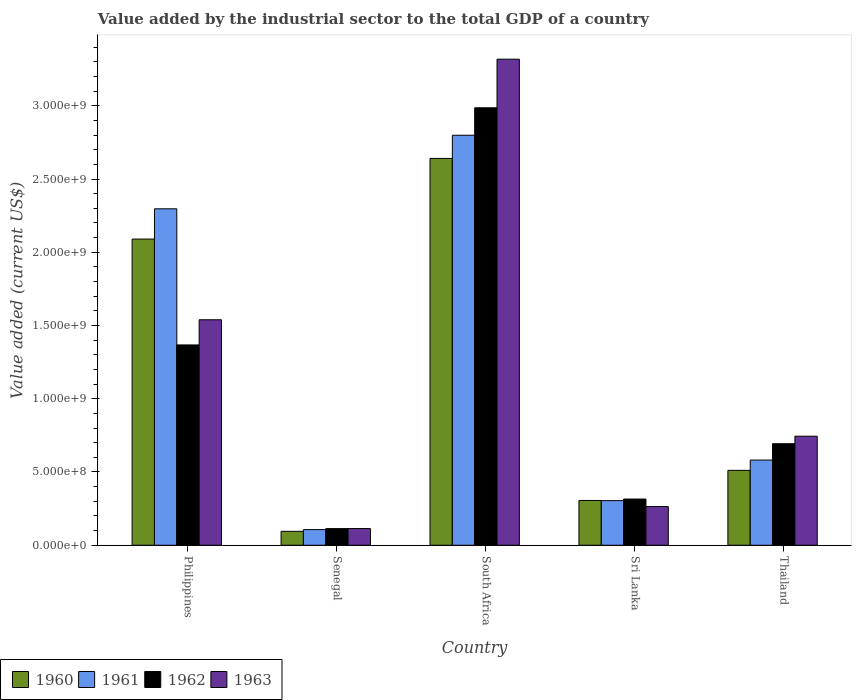How many different coloured bars are there?
Your answer should be compact. 4. How many groups of bars are there?
Offer a very short reply. 5. Are the number of bars per tick equal to the number of legend labels?
Provide a short and direct response. Yes. Are the number of bars on each tick of the X-axis equal?
Provide a succinct answer. Yes. How many bars are there on the 3rd tick from the right?
Provide a succinct answer. 4. What is the label of the 4th group of bars from the left?
Keep it short and to the point. Sri Lanka. In how many cases, is the number of bars for a given country not equal to the number of legend labels?
Offer a very short reply. 0. What is the value added by the industrial sector to the total GDP in 1963 in Sri Lanka?
Offer a very short reply. 2.64e+08. Across all countries, what is the maximum value added by the industrial sector to the total GDP in 1961?
Offer a terse response. 2.80e+09. Across all countries, what is the minimum value added by the industrial sector to the total GDP in 1962?
Provide a succinct answer. 1.13e+08. In which country was the value added by the industrial sector to the total GDP in 1961 maximum?
Your answer should be very brief. South Africa. In which country was the value added by the industrial sector to the total GDP in 1963 minimum?
Keep it short and to the point. Senegal. What is the total value added by the industrial sector to the total GDP in 1962 in the graph?
Provide a short and direct response. 5.48e+09. What is the difference between the value added by the industrial sector to the total GDP in 1962 in South Africa and that in Sri Lanka?
Provide a succinct answer. 2.67e+09. What is the difference between the value added by the industrial sector to the total GDP in 1962 in South Africa and the value added by the industrial sector to the total GDP in 1960 in Thailand?
Your answer should be very brief. 2.48e+09. What is the average value added by the industrial sector to the total GDP in 1962 per country?
Provide a short and direct response. 1.10e+09. What is the difference between the value added by the industrial sector to the total GDP of/in 1962 and value added by the industrial sector to the total GDP of/in 1963 in Senegal?
Give a very brief answer. -4.40e+05. What is the ratio of the value added by the industrial sector to the total GDP in 1963 in Senegal to that in Thailand?
Provide a short and direct response. 0.15. What is the difference between the highest and the second highest value added by the industrial sector to the total GDP in 1962?
Provide a short and direct response. 6.74e+08. What is the difference between the highest and the lowest value added by the industrial sector to the total GDP in 1960?
Keep it short and to the point. 2.55e+09. In how many countries, is the value added by the industrial sector to the total GDP in 1962 greater than the average value added by the industrial sector to the total GDP in 1962 taken over all countries?
Give a very brief answer. 2. Is the sum of the value added by the industrial sector to the total GDP in 1960 in Philippines and South Africa greater than the maximum value added by the industrial sector to the total GDP in 1963 across all countries?
Offer a very short reply. Yes. What does the 1st bar from the left in South Africa represents?
Offer a very short reply. 1960. What does the 4th bar from the right in Sri Lanka represents?
Provide a short and direct response. 1960. Is it the case that in every country, the sum of the value added by the industrial sector to the total GDP in 1961 and value added by the industrial sector to the total GDP in 1963 is greater than the value added by the industrial sector to the total GDP in 1962?
Ensure brevity in your answer.  Yes. How many bars are there?
Offer a very short reply. 20. What is the difference between two consecutive major ticks on the Y-axis?
Offer a terse response. 5.00e+08. Does the graph contain any zero values?
Keep it short and to the point. No. How many legend labels are there?
Your answer should be compact. 4. What is the title of the graph?
Provide a succinct answer. Value added by the industrial sector to the total GDP of a country. Does "2003" appear as one of the legend labels in the graph?
Your response must be concise. No. What is the label or title of the Y-axis?
Your response must be concise. Value added (current US$). What is the Value added (current US$) in 1960 in Philippines?
Your answer should be very brief. 2.09e+09. What is the Value added (current US$) in 1961 in Philippines?
Your answer should be compact. 2.30e+09. What is the Value added (current US$) in 1962 in Philippines?
Provide a succinct answer. 1.37e+09. What is the Value added (current US$) of 1963 in Philippines?
Your response must be concise. 1.54e+09. What is the Value added (current US$) of 1960 in Senegal?
Your answer should be very brief. 9.49e+07. What is the Value added (current US$) of 1961 in Senegal?
Offer a very short reply. 1.07e+08. What is the Value added (current US$) of 1962 in Senegal?
Make the answer very short. 1.13e+08. What is the Value added (current US$) in 1963 in Senegal?
Offer a very short reply. 1.14e+08. What is the Value added (current US$) of 1960 in South Africa?
Give a very brief answer. 2.64e+09. What is the Value added (current US$) in 1961 in South Africa?
Provide a succinct answer. 2.80e+09. What is the Value added (current US$) in 1962 in South Africa?
Your response must be concise. 2.99e+09. What is the Value added (current US$) in 1963 in South Africa?
Offer a terse response. 3.32e+09. What is the Value added (current US$) in 1960 in Sri Lanka?
Give a very brief answer. 3.06e+08. What is the Value added (current US$) of 1961 in Sri Lanka?
Ensure brevity in your answer.  3.04e+08. What is the Value added (current US$) in 1962 in Sri Lanka?
Keep it short and to the point. 3.15e+08. What is the Value added (current US$) of 1963 in Sri Lanka?
Offer a very short reply. 2.64e+08. What is the Value added (current US$) in 1960 in Thailand?
Offer a very short reply. 5.11e+08. What is the Value added (current US$) in 1961 in Thailand?
Give a very brief answer. 5.81e+08. What is the Value added (current US$) in 1962 in Thailand?
Your answer should be compact. 6.93e+08. What is the Value added (current US$) in 1963 in Thailand?
Your response must be concise. 7.44e+08. Across all countries, what is the maximum Value added (current US$) of 1960?
Ensure brevity in your answer.  2.64e+09. Across all countries, what is the maximum Value added (current US$) in 1961?
Keep it short and to the point. 2.80e+09. Across all countries, what is the maximum Value added (current US$) in 1962?
Your response must be concise. 2.99e+09. Across all countries, what is the maximum Value added (current US$) in 1963?
Offer a terse response. 3.32e+09. Across all countries, what is the minimum Value added (current US$) in 1960?
Offer a terse response. 9.49e+07. Across all countries, what is the minimum Value added (current US$) of 1961?
Your response must be concise. 1.07e+08. Across all countries, what is the minimum Value added (current US$) in 1962?
Your response must be concise. 1.13e+08. Across all countries, what is the minimum Value added (current US$) of 1963?
Your response must be concise. 1.14e+08. What is the total Value added (current US$) of 1960 in the graph?
Provide a succinct answer. 5.64e+09. What is the total Value added (current US$) in 1961 in the graph?
Provide a short and direct response. 6.09e+09. What is the total Value added (current US$) in 1962 in the graph?
Your answer should be compact. 5.48e+09. What is the total Value added (current US$) in 1963 in the graph?
Your response must be concise. 5.98e+09. What is the difference between the Value added (current US$) of 1960 in Philippines and that in Senegal?
Your response must be concise. 2.00e+09. What is the difference between the Value added (current US$) of 1961 in Philippines and that in Senegal?
Your response must be concise. 2.19e+09. What is the difference between the Value added (current US$) of 1962 in Philippines and that in Senegal?
Your answer should be very brief. 1.25e+09. What is the difference between the Value added (current US$) of 1963 in Philippines and that in Senegal?
Provide a succinct answer. 1.43e+09. What is the difference between the Value added (current US$) of 1960 in Philippines and that in South Africa?
Provide a succinct answer. -5.50e+08. What is the difference between the Value added (current US$) in 1961 in Philippines and that in South Africa?
Your response must be concise. -5.02e+08. What is the difference between the Value added (current US$) of 1962 in Philippines and that in South Africa?
Make the answer very short. -1.62e+09. What is the difference between the Value added (current US$) of 1963 in Philippines and that in South Africa?
Provide a succinct answer. -1.78e+09. What is the difference between the Value added (current US$) of 1960 in Philippines and that in Sri Lanka?
Ensure brevity in your answer.  1.78e+09. What is the difference between the Value added (current US$) of 1961 in Philippines and that in Sri Lanka?
Offer a very short reply. 1.99e+09. What is the difference between the Value added (current US$) of 1962 in Philippines and that in Sri Lanka?
Make the answer very short. 1.05e+09. What is the difference between the Value added (current US$) in 1963 in Philippines and that in Sri Lanka?
Offer a very short reply. 1.28e+09. What is the difference between the Value added (current US$) in 1960 in Philippines and that in Thailand?
Keep it short and to the point. 1.58e+09. What is the difference between the Value added (current US$) of 1961 in Philippines and that in Thailand?
Your answer should be compact. 1.72e+09. What is the difference between the Value added (current US$) in 1962 in Philippines and that in Thailand?
Keep it short and to the point. 6.74e+08. What is the difference between the Value added (current US$) in 1963 in Philippines and that in Thailand?
Make the answer very short. 7.95e+08. What is the difference between the Value added (current US$) in 1960 in Senegal and that in South Africa?
Your answer should be very brief. -2.55e+09. What is the difference between the Value added (current US$) in 1961 in Senegal and that in South Africa?
Provide a succinct answer. -2.69e+09. What is the difference between the Value added (current US$) of 1962 in Senegal and that in South Africa?
Make the answer very short. -2.87e+09. What is the difference between the Value added (current US$) in 1963 in Senegal and that in South Africa?
Give a very brief answer. -3.20e+09. What is the difference between the Value added (current US$) of 1960 in Senegal and that in Sri Lanka?
Your answer should be very brief. -2.11e+08. What is the difference between the Value added (current US$) of 1961 in Senegal and that in Sri Lanka?
Your response must be concise. -1.98e+08. What is the difference between the Value added (current US$) of 1962 in Senegal and that in Sri Lanka?
Your answer should be very brief. -2.02e+08. What is the difference between the Value added (current US$) in 1963 in Senegal and that in Sri Lanka?
Your answer should be compact. -1.50e+08. What is the difference between the Value added (current US$) of 1960 in Senegal and that in Thailand?
Make the answer very short. -4.16e+08. What is the difference between the Value added (current US$) in 1961 in Senegal and that in Thailand?
Provide a succinct answer. -4.75e+08. What is the difference between the Value added (current US$) in 1962 in Senegal and that in Thailand?
Your answer should be compact. -5.79e+08. What is the difference between the Value added (current US$) of 1963 in Senegal and that in Thailand?
Offer a very short reply. -6.31e+08. What is the difference between the Value added (current US$) of 1960 in South Africa and that in Sri Lanka?
Ensure brevity in your answer.  2.33e+09. What is the difference between the Value added (current US$) in 1961 in South Africa and that in Sri Lanka?
Your answer should be very brief. 2.49e+09. What is the difference between the Value added (current US$) of 1962 in South Africa and that in Sri Lanka?
Provide a short and direct response. 2.67e+09. What is the difference between the Value added (current US$) in 1963 in South Africa and that in Sri Lanka?
Your response must be concise. 3.05e+09. What is the difference between the Value added (current US$) in 1960 in South Africa and that in Thailand?
Keep it short and to the point. 2.13e+09. What is the difference between the Value added (current US$) in 1961 in South Africa and that in Thailand?
Keep it short and to the point. 2.22e+09. What is the difference between the Value added (current US$) in 1962 in South Africa and that in Thailand?
Make the answer very short. 2.29e+09. What is the difference between the Value added (current US$) in 1963 in South Africa and that in Thailand?
Keep it short and to the point. 2.57e+09. What is the difference between the Value added (current US$) of 1960 in Sri Lanka and that in Thailand?
Your response must be concise. -2.06e+08. What is the difference between the Value added (current US$) in 1961 in Sri Lanka and that in Thailand?
Give a very brief answer. -2.77e+08. What is the difference between the Value added (current US$) in 1962 in Sri Lanka and that in Thailand?
Give a very brief answer. -3.78e+08. What is the difference between the Value added (current US$) in 1963 in Sri Lanka and that in Thailand?
Your answer should be very brief. -4.80e+08. What is the difference between the Value added (current US$) of 1960 in Philippines and the Value added (current US$) of 1961 in Senegal?
Offer a terse response. 1.98e+09. What is the difference between the Value added (current US$) in 1960 in Philippines and the Value added (current US$) in 1962 in Senegal?
Give a very brief answer. 1.98e+09. What is the difference between the Value added (current US$) in 1960 in Philippines and the Value added (current US$) in 1963 in Senegal?
Keep it short and to the point. 1.98e+09. What is the difference between the Value added (current US$) of 1961 in Philippines and the Value added (current US$) of 1962 in Senegal?
Give a very brief answer. 2.18e+09. What is the difference between the Value added (current US$) of 1961 in Philippines and the Value added (current US$) of 1963 in Senegal?
Give a very brief answer. 2.18e+09. What is the difference between the Value added (current US$) in 1962 in Philippines and the Value added (current US$) in 1963 in Senegal?
Offer a terse response. 1.25e+09. What is the difference between the Value added (current US$) of 1960 in Philippines and the Value added (current US$) of 1961 in South Africa?
Your answer should be compact. -7.09e+08. What is the difference between the Value added (current US$) of 1960 in Philippines and the Value added (current US$) of 1962 in South Africa?
Provide a short and direct response. -8.96e+08. What is the difference between the Value added (current US$) in 1960 in Philippines and the Value added (current US$) in 1963 in South Africa?
Provide a short and direct response. -1.23e+09. What is the difference between the Value added (current US$) of 1961 in Philippines and the Value added (current US$) of 1962 in South Africa?
Your answer should be compact. -6.90e+08. What is the difference between the Value added (current US$) of 1961 in Philippines and the Value added (current US$) of 1963 in South Africa?
Offer a very short reply. -1.02e+09. What is the difference between the Value added (current US$) in 1962 in Philippines and the Value added (current US$) in 1963 in South Africa?
Ensure brevity in your answer.  -1.95e+09. What is the difference between the Value added (current US$) in 1960 in Philippines and the Value added (current US$) in 1961 in Sri Lanka?
Ensure brevity in your answer.  1.79e+09. What is the difference between the Value added (current US$) in 1960 in Philippines and the Value added (current US$) in 1962 in Sri Lanka?
Provide a short and direct response. 1.77e+09. What is the difference between the Value added (current US$) in 1960 in Philippines and the Value added (current US$) in 1963 in Sri Lanka?
Ensure brevity in your answer.  1.83e+09. What is the difference between the Value added (current US$) of 1961 in Philippines and the Value added (current US$) of 1962 in Sri Lanka?
Your answer should be compact. 1.98e+09. What is the difference between the Value added (current US$) in 1961 in Philippines and the Value added (current US$) in 1963 in Sri Lanka?
Make the answer very short. 2.03e+09. What is the difference between the Value added (current US$) in 1962 in Philippines and the Value added (current US$) in 1963 in Sri Lanka?
Ensure brevity in your answer.  1.10e+09. What is the difference between the Value added (current US$) in 1960 in Philippines and the Value added (current US$) in 1961 in Thailand?
Provide a short and direct response. 1.51e+09. What is the difference between the Value added (current US$) in 1960 in Philippines and the Value added (current US$) in 1962 in Thailand?
Offer a terse response. 1.40e+09. What is the difference between the Value added (current US$) of 1960 in Philippines and the Value added (current US$) of 1963 in Thailand?
Your response must be concise. 1.35e+09. What is the difference between the Value added (current US$) in 1961 in Philippines and the Value added (current US$) in 1962 in Thailand?
Your response must be concise. 1.60e+09. What is the difference between the Value added (current US$) of 1961 in Philippines and the Value added (current US$) of 1963 in Thailand?
Make the answer very short. 1.55e+09. What is the difference between the Value added (current US$) of 1962 in Philippines and the Value added (current US$) of 1963 in Thailand?
Keep it short and to the point. 6.23e+08. What is the difference between the Value added (current US$) in 1960 in Senegal and the Value added (current US$) in 1961 in South Africa?
Provide a succinct answer. -2.70e+09. What is the difference between the Value added (current US$) of 1960 in Senegal and the Value added (current US$) of 1962 in South Africa?
Make the answer very short. -2.89e+09. What is the difference between the Value added (current US$) in 1960 in Senegal and the Value added (current US$) in 1963 in South Africa?
Provide a succinct answer. -3.22e+09. What is the difference between the Value added (current US$) of 1961 in Senegal and the Value added (current US$) of 1962 in South Africa?
Make the answer very short. -2.88e+09. What is the difference between the Value added (current US$) in 1961 in Senegal and the Value added (current US$) in 1963 in South Africa?
Your response must be concise. -3.21e+09. What is the difference between the Value added (current US$) in 1962 in Senegal and the Value added (current US$) in 1963 in South Africa?
Make the answer very short. -3.20e+09. What is the difference between the Value added (current US$) in 1960 in Senegal and the Value added (current US$) in 1961 in Sri Lanka?
Your response must be concise. -2.10e+08. What is the difference between the Value added (current US$) in 1960 in Senegal and the Value added (current US$) in 1962 in Sri Lanka?
Your answer should be compact. -2.20e+08. What is the difference between the Value added (current US$) of 1960 in Senegal and the Value added (current US$) of 1963 in Sri Lanka?
Your answer should be compact. -1.69e+08. What is the difference between the Value added (current US$) of 1961 in Senegal and the Value added (current US$) of 1962 in Sri Lanka?
Provide a short and direct response. -2.08e+08. What is the difference between the Value added (current US$) of 1961 in Senegal and the Value added (current US$) of 1963 in Sri Lanka?
Your answer should be very brief. -1.57e+08. What is the difference between the Value added (current US$) in 1962 in Senegal and the Value added (current US$) in 1963 in Sri Lanka?
Keep it short and to the point. -1.51e+08. What is the difference between the Value added (current US$) of 1960 in Senegal and the Value added (current US$) of 1961 in Thailand?
Offer a very short reply. -4.87e+08. What is the difference between the Value added (current US$) of 1960 in Senegal and the Value added (current US$) of 1962 in Thailand?
Your answer should be very brief. -5.98e+08. What is the difference between the Value added (current US$) in 1960 in Senegal and the Value added (current US$) in 1963 in Thailand?
Keep it short and to the point. -6.50e+08. What is the difference between the Value added (current US$) in 1961 in Senegal and the Value added (current US$) in 1962 in Thailand?
Make the answer very short. -5.86e+08. What is the difference between the Value added (current US$) in 1961 in Senegal and the Value added (current US$) in 1963 in Thailand?
Provide a succinct answer. -6.38e+08. What is the difference between the Value added (current US$) in 1962 in Senegal and the Value added (current US$) in 1963 in Thailand?
Keep it short and to the point. -6.31e+08. What is the difference between the Value added (current US$) in 1960 in South Africa and the Value added (current US$) in 1961 in Sri Lanka?
Make the answer very short. 2.34e+09. What is the difference between the Value added (current US$) of 1960 in South Africa and the Value added (current US$) of 1962 in Sri Lanka?
Your answer should be compact. 2.33e+09. What is the difference between the Value added (current US$) of 1960 in South Africa and the Value added (current US$) of 1963 in Sri Lanka?
Provide a succinct answer. 2.38e+09. What is the difference between the Value added (current US$) in 1961 in South Africa and the Value added (current US$) in 1962 in Sri Lanka?
Make the answer very short. 2.48e+09. What is the difference between the Value added (current US$) in 1961 in South Africa and the Value added (current US$) in 1963 in Sri Lanka?
Keep it short and to the point. 2.53e+09. What is the difference between the Value added (current US$) of 1962 in South Africa and the Value added (current US$) of 1963 in Sri Lanka?
Provide a short and direct response. 2.72e+09. What is the difference between the Value added (current US$) in 1960 in South Africa and the Value added (current US$) in 1961 in Thailand?
Ensure brevity in your answer.  2.06e+09. What is the difference between the Value added (current US$) in 1960 in South Africa and the Value added (current US$) in 1962 in Thailand?
Provide a succinct answer. 1.95e+09. What is the difference between the Value added (current US$) in 1960 in South Africa and the Value added (current US$) in 1963 in Thailand?
Your answer should be compact. 1.90e+09. What is the difference between the Value added (current US$) of 1961 in South Africa and the Value added (current US$) of 1962 in Thailand?
Your answer should be compact. 2.11e+09. What is the difference between the Value added (current US$) of 1961 in South Africa and the Value added (current US$) of 1963 in Thailand?
Offer a very short reply. 2.05e+09. What is the difference between the Value added (current US$) in 1962 in South Africa and the Value added (current US$) in 1963 in Thailand?
Make the answer very short. 2.24e+09. What is the difference between the Value added (current US$) of 1960 in Sri Lanka and the Value added (current US$) of 1961 in Thailand?
Offer a terse response. -2.76e+08. What is the difference between the Value added (current US$) of 1960 in Sri Lanka and the Value added (current US$) of 1962 in Thailand?
Your answer should be compact. -3.87e+08. What is the difference between the Value added (current US$) of 1960 in Sri Lanka and the Value added (current US$) of 1963 in Thailand?
Keep it short and to the point. -4.39e+08. What is the difference between the Value added (current US$) in 1961 in Sri Lanka and the Value added (current US$) in 1962 in Thailand?
Offer a very short reply. -3.89e+08. What is the difference between the Value added (current US$) in 1961 in Sri Lanka and the Value added (current US$) in 1963 in Thailand?
Your answer should be compact. -4.40e+08. What is the difference between the Value added (current US$) of 1962 in Sri Lanka and the Value added (current US$) of 1963 in Thailand?
Ensure brevity in your answer.  -4.29e+08. What is the average Value added (current US$) in 1960 per country?
Keep it short and to the point. 1.13e+09. What is the average Value added (current US$) in 1961 per country?
Offer a terse response. 1.22e+09. What is the average Value added (current US$) of 1962 per country?
Keep it short and to the point. 1.10e+09. What is the average Value added (current US$) of 1963 per country?
Provide a short and direct response. 1.20e+09. What is the difference between the Value added (current US$) in 1960 and Value added (current US$) in 1961 in Philippines?
Offer a very short reply. -2.07e+08. What is the difference between the Value added (current US$) in 1960 and Value added (current US$) in 1962 in Philippines?
Your answer should be very brief. 7.23e+08. What is the difference between the Value added (current US$) in 1960 and Value added (current US$) in 1963 in Philippines?
Your answer should be very brief. 5.51e+08. What is the difference between the Value added (current US$) of 1961 and Value added (current US$) of 1962 in Philippines?
Offer a very short reply. 9.29e+08. What is the difference between the Value added (current US$) of 1961 and Value added (current US$) of 1963 in Philippines?
Make the answer very short. 7.57e+08. What is the difference between the Value added (current US$) of 1962 and Value added (current US$) of 1963 in Philippines?
Your answer should be very brief. -1.72e+08. What is the difference between the Value added (current US$) in 1960 and Value added (current US$) in 1961 in Senegal?
Provide a short and direct response. -1.19e+07. What is the difference between the Value added (current US$) of 1960 and Value added (current US$) of 1962 in Senegal?
Your answer should be compact. -1.86e+07. What is the difference between the Value added (current US$) of 1960 and Value added (current US$) of 1963 in Senegal?
Your answer should be compact. -1.91e+07. What is the difference between the Value added (current US$) of 1961 and Value added (current US$) of 1962 in Senegal?
Provide a succinct answer. -6.73e+06. What is the difference between the Value added (current US$) of 1961 and Value added (current US$) of 1963 in Senegal?
Make the answer very short. -7.17e+06. What is the difference between the Value added (current US$) of 1962 and Value added (current US$) of 1963 in Senegal?
Provide a short and direct response. -4.40e+05. What is the difference between the Value added (current US$) of 1960 and Value added (current US$) of 1961 in South Africa?
Give a very brief answer. -1.58e+08. What is the difference between the Value added (current US$) of 1960 and Value added (current US$) of 1962 in South Africa?
Give a very brief answer. -3.46e+08. What is the difference between the Value added (current US$) in 1960 and Value added (current US$) in 1963 in South Africa?
Your answer should be compact. -6.78e+08. What is the difference between the Value added (current US$) in 1961 and Value added (current US$) in 1962 in South Africa?
Provide a short and direct response. -1.87e+08. What is the difference between the Value added (current US$) of 1961 and Value added (current US$) of 1963 in South Africa?
Offer a terse response. -5.19e+08. What is the difference between the Value added (current US$) in 1962 and Value added (current US$) in 1963 in South Africa?
Offer a terse response. -3.32e+08. What is the difference between the Value added (current US$) of 1960 and Value added (current US$) of 1961 in Sri Lanka?
Your response must be concise. 1.26e+06. What is the difference between the Value added (current US$) of 1960 and Value added (current US$) of 1962 in Sri Lanka?
Offer a very short reply. -9.55e+06. What is the difference between the Value added (current US$) of 1960 and Value added (current US$) of 1963 in Sri Lanka?
Make the answer very short. 4.16e+07. What is the difference between the Value added (current US$) in 1961 and Value added (current US$) in 1962 in Sri Lanka?
Your answer should be compact. -1.08e+07. What is the difference between the Value added (current US$) in 1961 and Value added (current US$) in 1963 in Sri Lanka?
Your response must be concise. 4.04e+07. What is the difference between the Value added (current US$) in 1962 and Value added (current US$) in 1963 in Sri Lanka?
Ensure brevity in your answer.  5.12e+07. What is the difference between the Value added (current US$) in 1960 and Value added (current US$) in 1961 in Thailand?
Provide a short and direct response. -7.03e+07. What is the difference between the Value added (current US$) in 1960 and Value added (current US$) in 1962 in Thailand?
Offer a terse response. -1.82e+08. What is the difference between the Value added (current US$) in 1960 and Value added (current US$) in 1963 in Thailand?
Offer a very short reply. -2.33e+08. What is the difference between the Value added (current US$) in 1961 and Value added (current US$) in 1962 in Thailand?
Give a very brief answer. -1.12e+08. What is the difference between the Value added (current US$) in 1961 and Value added (current US$) in 1963 in Thailand?
Keep it short and to the point. -1.63e+08. What is the difference between the Value added (current US$) in 1962 and Value added (current US$) in 1963 in Thailand?
Offer a very short reply. -5.15e+07. What is the ratio of the Value added (current US$) of 1960 in Philippines to that in Senegal?
Your answer should be compact. 22.03. What is the ratio of the Value added (current US$) in 1961 in Philippines to that in Senegal?
Provide a succinct answer. 21.51. What is the ratio of the Value added (current US$) of 1962 in Philippines to that in Senegal?
Give a very brief answer. 12.05. What is the ratio of the Value added (current US$) in 1963 in Philippines to that in Senegal?
Offer a terse response. 13.51. What is the ratio of the Value added (current US$) of 1960 in Philippines to that in South Africa?
Your response must be concise. 0.79. What is the ratio of the Value added (current US$) of 1961 in Philippines to that in South Africa?
Your answer should be very brief. 0.82. What is the ratio of the Value added (current US$) of 1962 in Philippines to that in South Africa?
Make the answer very short. 0.46. What is the ratio of the Value added (current US$) of 1963 in Philippines to that in South Africa?
Your answer should be compact. 0.46. What is the ratio of the Value added (current US$) of 1960 in Philippines to that in Sri Lanka?
Give a very brief answer. 6.84. What is the ratio of the Value added (current US$) of 1961 in Philippines to that in Sri Lanka?
Provide a short and direct response. 7.54. What is the ratio of the Value added (current US$) of 1962 in Philippines to that in Sri Lanka?
Your response must be concise. 4.34. What is the ratio of the Value added (current US$) of 1963 in Philippines to that in Sri Lanka?
Keep it short and to the point. 5.83. What is the ratio of the Value added (current US$) of 1960 in Philippines to that in Thailand?
Give a very brief answer. 4.09. What is the ratio of the Value added (current US$) in 1961 in Philippines to that in Thailand?
Offer a terse response. 3.95. What is the ratio of the Value added (current US$) in 1962 in Philippines to that in Thailand?
Offer a very short reply. 1.97. What is the ratio of the Value added (current US$) of 1963 in Philippines to that in Thailand?
Give a very brief answer. 2.07. What is the ratio of the Value added (current US$) of 1960 in Senegal to that in South Africa?
Make the answer very short. 0.04. What is the ratio of the Value added (current US$) in 1961 in Senegal to that in South Africa?
Provide a short and direct response. 0.04. What is the ratio of the Value added (current US$) in 1962 in Senegal to that in South Africa?
Provide a short and direct response. 0.04. What is the ratio of the Value added (current US$) in 1963 in Senegal to that in South Africa?
Provide a succinct answer. 0.03. What is the ratio of the Value added (current US$) of 1960 in Senegal to that in Sri Lanka?
Provide a succinct answer. 0.31. What is the ratio of the Value added (current US$) in 1961 in Senegal to that in Sri Lanka?
Your response must be concise. 0.35. What is the ratio of the Value added (current US$) of 1962 in Senegal to that in Sri Lanka?
Your answer should be very brief. 0.36. What is the ratio of the Value added (current US$) in 1963 in Senegal to that in Sri Lanka?
Offer a very short reply. 0.43. What is the ratio of the Value added (current US$) in 1960 in Senegal to that in Thailand?
Your answer should be compact. 0.19. What is the ratio of the Value added (current US$) of 1961 in Senegal to that in Thailand?
Offer a terse response. 0.18. What is the ratio of the Value added (current US$) of 1962 in Senegal to that in Thailand?
Provide a short and direct response. 0.16. What is the ratio of the Value added (current US$) in 1963 in Senegal to that in Thailand?
Keep it short and to the point. 0.15. What is the ratio of the Value added (current US$) in 1960 in South Africa to that in Sri Lanka?
Make the answer very short. 8.64. What is the ratio of the Value added (current US$) of 1961 in South Africa to that in Sri Lanka?
Keep it short and to the point. 9.19. What is the ratio of the Value added (current US$) of 1962 in South Africa to that in Sri Lanka?
Offer a very short reply. 9.47. What is the ratio of the Value added (current US$) in 1963 in South Africa to that in Sri Lanka?
Keep it short and to the point. 12.57. What is the ratio of the Value added (current US$) in 1960 in South Africa to that in Thailand?
Keep it short and to the point. 5.17. What is the ratio of the Value added (current US$) of 1961 in South Africa to that in Thailand?
Offer a terse response. 4.81. What is the ratio of the Value added (current US$) in 1962 in South Africa to that in Thailand?
Your answer should be compact. 4.31. What is the ratio of the Value added (current US$) of 1963 in South Africa to that in Thailand?
Offer a very short reply. 4.46. What is the ratio of the Value added (current US$) of 1960 in Sri Lanka to that in Thailand?
Your answer should be compact. 0.6. What is the ratio of the Value added (current US$) in 1961 in Sri Lanka to that in Thailand?
Your response must be concise. 0.52. What is the ratio of the Value added (current US$) of 1962 in Sri Lanka to that in Thailand?
Offer a terse response. 0.45. What is the ratio of the Value added (current US$) in 1963 in Sri Lanka to that in Thailand?
Keep it short and to the point. 0.35. What is the difference between the highest and the second highest Value added (current US$) in 1960?
Your answer should be very brief. 5.50e+08. What is the difference between the highest and the second highest Value added (current US$) of 1961?
Your response must be concise. 5.02e+08. What is the difference between the highest and the second highest Value added (current US$) in 1962?
Ensure brevity in your answer.  1.62e+09. What is the difference between the highest and the second highest Value added (current US$) in 1963?
Provide a short and direct response. 1.78e+09. What is the difference between the highest and the lowest Value added (current US$) in 1960?
Offer a very short reply. 2.55e+09. What is the difference between the highest and the lowest Value added (current US$) in 1961?
Your answer should be very brief. 2.69e+09. What is the difference between the highest and the lowest Value added (current US$) of 1962?
Make the answer very short. 2.87e+09. What is the difference between the highest and the lowest Value added (current US$) of 1963?
Offer a terse response. 3.20e+09. 